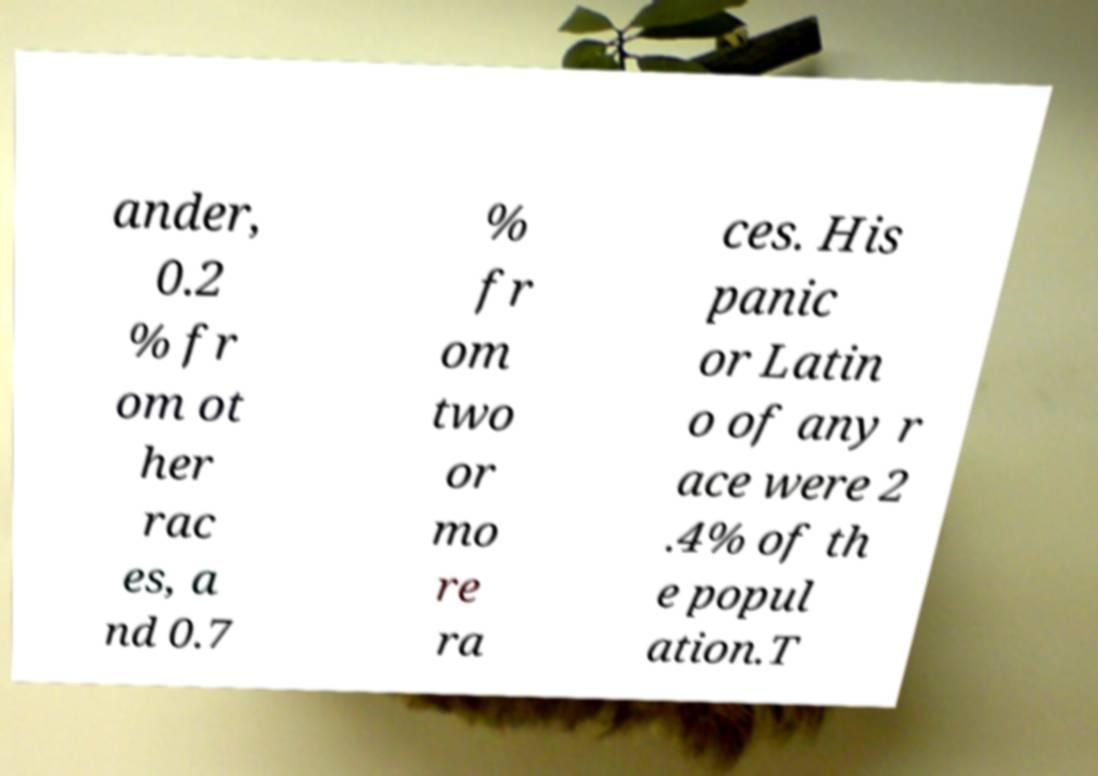I need the written content from this picture converted into text. Can you do that? ander, 0.2 % fr om ot her rac es, a nd 0.7 % fr om two or mo re ra ces. His panic or Latin o of any r ace were 2 .4% of th e popul ation.T 